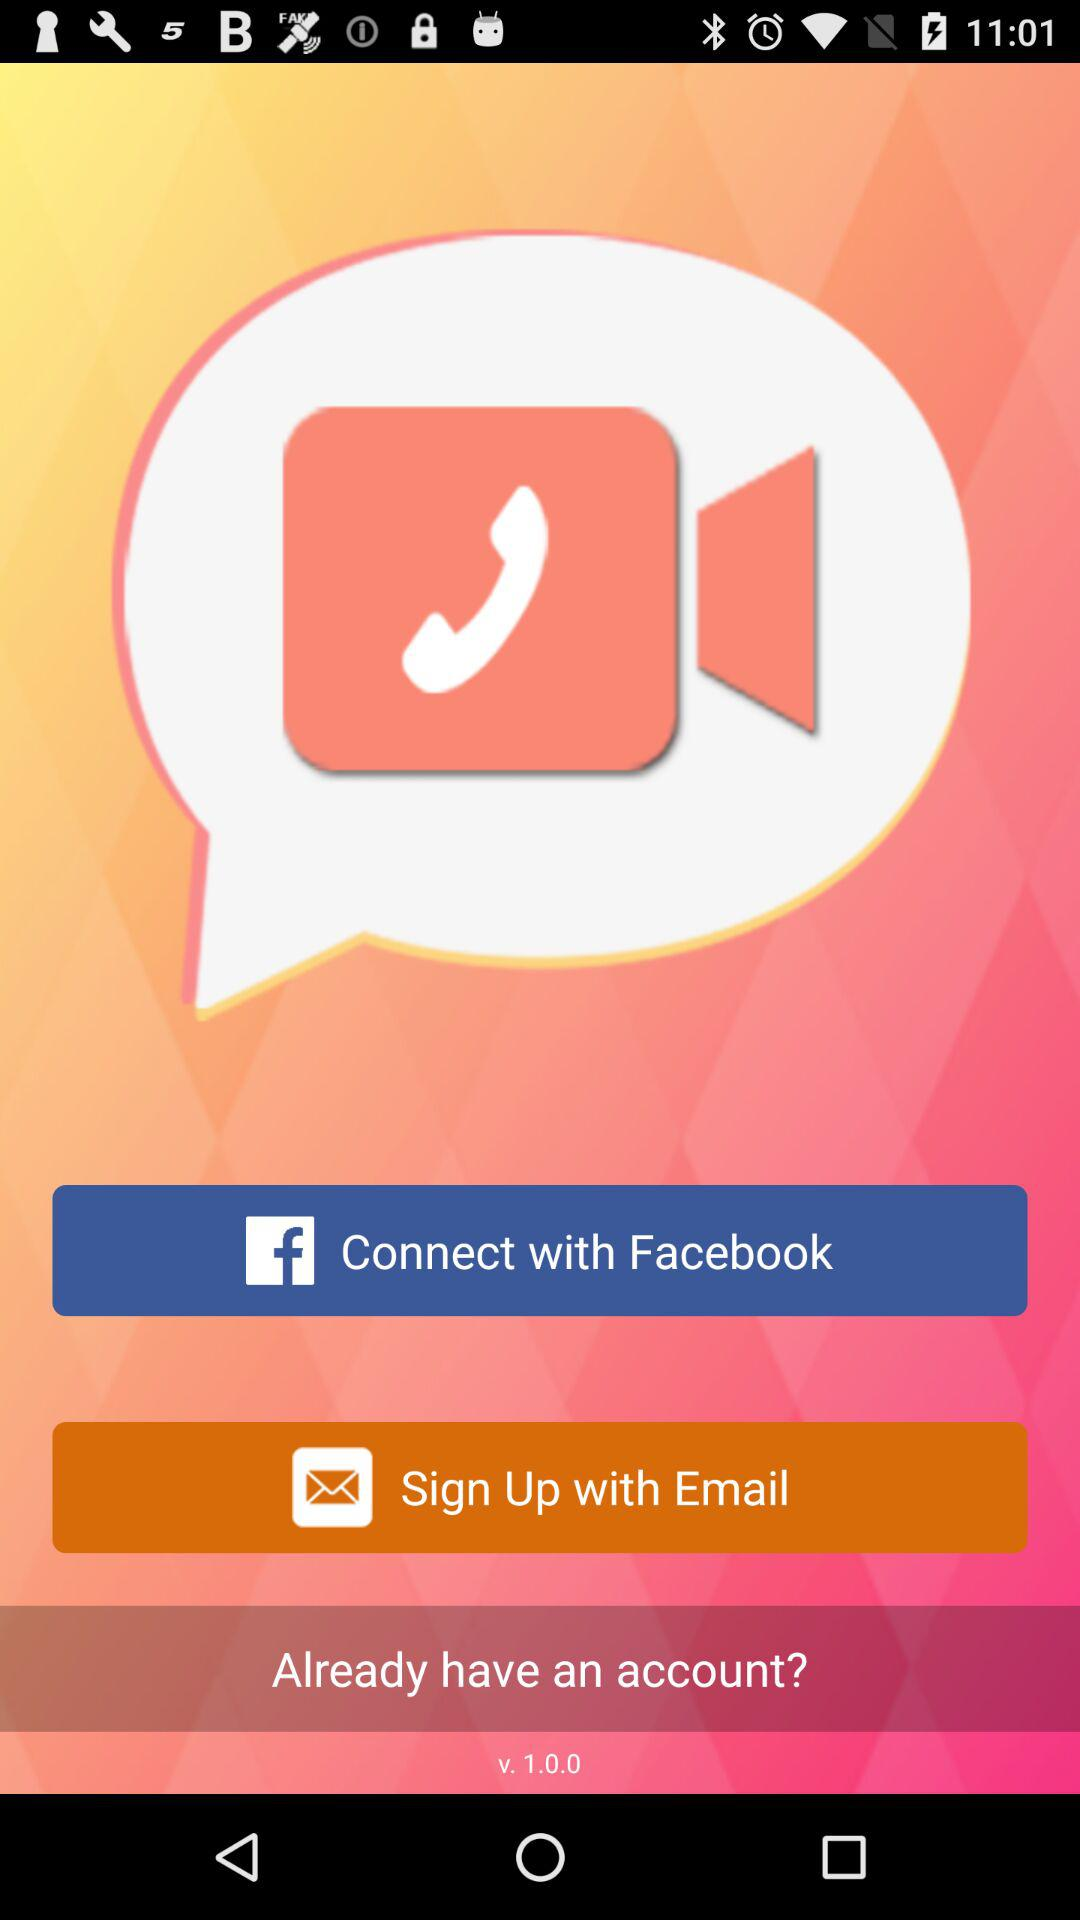What app can we use to connect? You can connect with "Facebook" and "Email". 